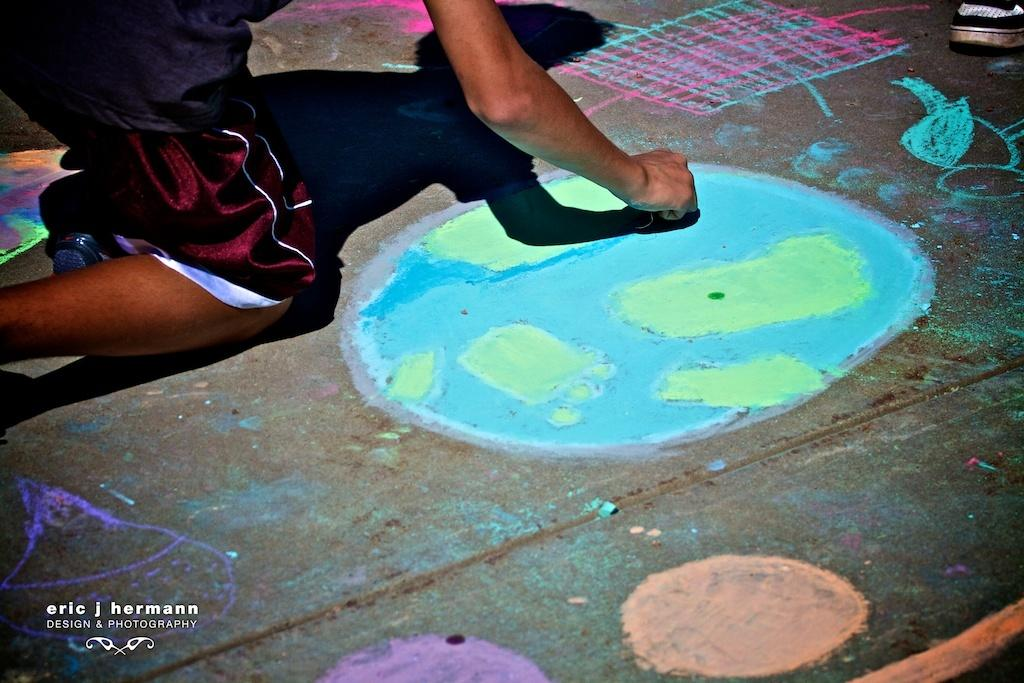What is the main subject of the image? There is a person in the image. What is the person doing in the image? The person is sitting on their knee and painting on the road. Is there any additional information about the image? There is a watermark in the bottom left corner of the image. What type of dirt can be seen in the image? There is no dirt visible in the image; it features a person painting on the road. Can you tell me how many animals are present in the zoo in the image? There is no zoo present in the image, as it focuses on a person painting on the road. 